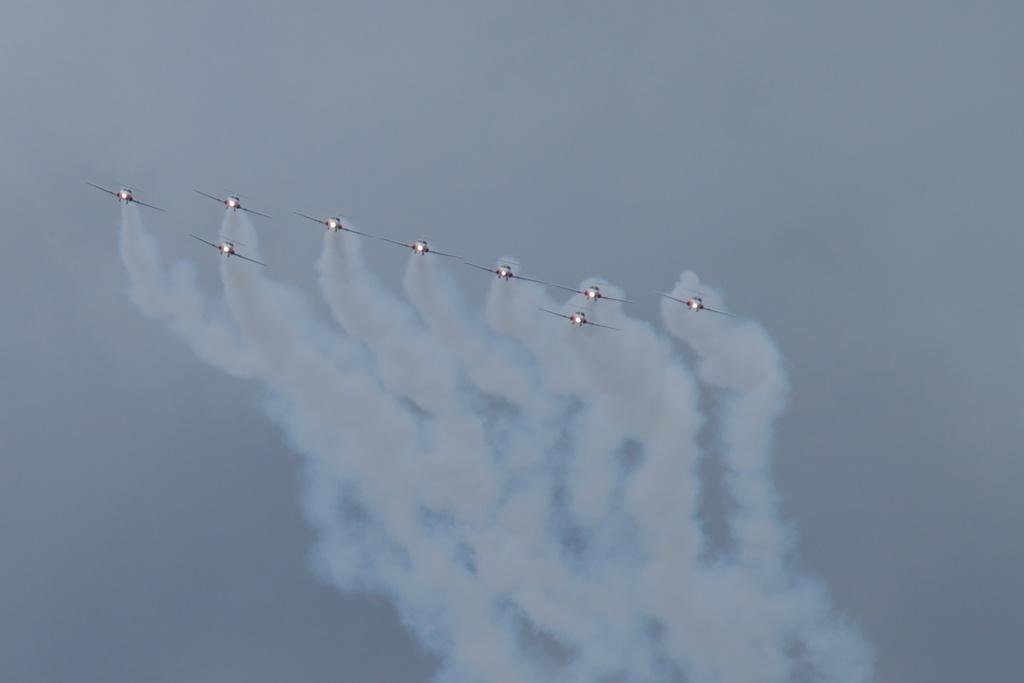Please provide a concise description of this image. In this image in the center there are some aircrafts and there is some fog coming out, and in the background there is sky. 